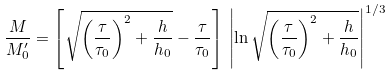Convert formula to latex. <formula><loc_0><loc_0><loc_500><loc_500>\frac { M } { M _ { 0 } ^ { \prime } } = \left [ \sqrt { \left ( \frac { \tau } { \tau _ { 0 } } \right ) ^ { 2 } + \frac { h } { h _ { 0 } } } - \frac { \tau } { \tau _ { 0 } } \right ] \, \left | \ln \sqrt { \left ( \frac { \tau } { \tau _ { 0 } } \right ) ^ { 2 } + \frac { h } { h _ { 0 } } } \right | ^ { 1 / 3 }</formula> 